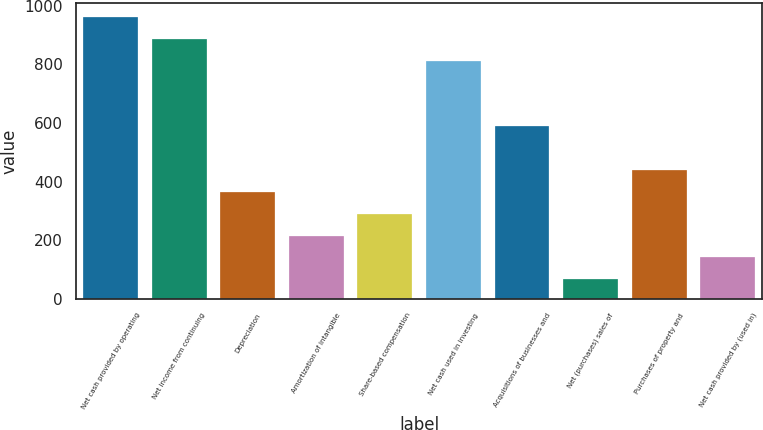<chart> <loc_0><loc_0><loc_500><loc_500><bar_chart><fcel>Net cash provided by operating<fcel>Net income from continuing<fcel>Depreciation<fcel>Amortization of intangible<fcel>Share-based compensation<fcel>Net cash used in investing<fcel>Acquisitions of businesses and<fcel>Net (purchases) sales of<fcel>Purchases of property and<fcel>Net cash provided by (used in)<nl><fcel>961.54<fcel>886.97<fcel>364.98<fcel>215.84<fcel>290.41<fcel>812.4<fcel>588.69<fcel>66.7<fcel>439.55<fcel>141.27<nl></chart> 